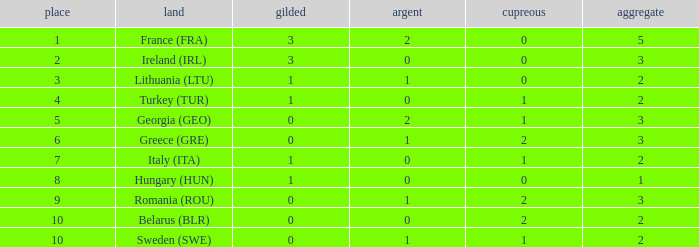What's the rank of Turkey (TUR) with a total more than 2? 0.0. 